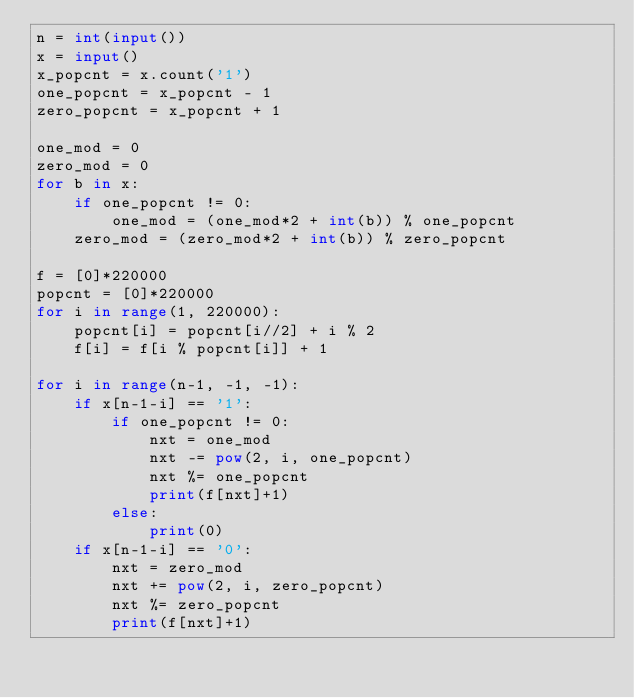<code> <loc_0><loc_0><loc_500><loc_500><_Python_>n = int(input())
x = input()
x_popcnt = x.count('1')
one_popcnt = x_popcnt - 1
zero_popcnt = x_popcnt + 1

one_mod = 0
zero_mod = 0
for b in x:
    if one_popcnt != 0:
        one_mod = (one_mod*2 + int(b)) % one_popcnt
    zero_mod = (zero_mod*2 + int(b)) % zero_popcnt

f = [0]*220000
popcnt = [0]*220000
for i in range(1, 220000):
    popcnt[i] = popcnt[i//2] + i % 2
    f[i] = f[i % popcnt[i]] + 1

for i in range(n-1, -1, -1):
    if x[n-1-i] == '1':
        if one_popcnt != 0:
            nxt = one_mod
            nxt -= pow(2, i, one_popcnt)
            nxt %= one_popcnt
            print(f[nxt]+1)
        else:
            print(0)
    if x[n-1-i] == '0':
        nxt = zero_mod
        nxt += pow(2, i, zero_popcnt)
        nxt %= zero_popcnt
        print(f[nxt]+1)
</code> 